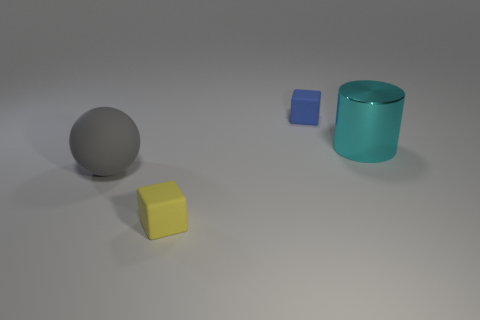There is a ball that is the same material as the blue cube; what color is it?
Make the answer very short. Gray. Is the cyan thing made of the same material as the thing left of the yellow thing?
Your answer should be very brief. No. The object that is right of the gray rubber object and in front of the big cyan cylinder is what color?
Offer a very short reply. Yellow. How many balls are either yellow rubber objects or gray things?
Your answer should be very brief. 1. There is a large cyan thing; does it have the same shape as the big object in front of the large cyan object?
Ensure brevity in your answer.  No. There is a object that is both behind the big gray ball and to the left of the large metal object; how big is it?
Provide a succinct answer. Small. The gray thing is what shape?
Make the answer very short. Sphere. There is a large thing on the left side of the large cyan cylinder; is there a object that is right of it?
Offer a terse response. Yes. How many blue rubber objects are behind the cube behind the yellow cube?
Your response must be concise. 0. What is the material of the cyan thing that is the same size as the ball?
Offer a terse response. Metal. 